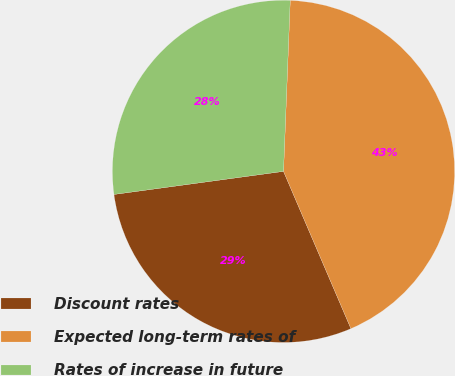Convert chart to OTSL. <chart><loc_0><loc_0><loc_500><loc_500><pie_chart><fcel>Discount rates<fcel>Expected long-term rates of<fcel>Rates of increase in future<nl><fcel>29.29%<fcel>42.93%<fcel>27.78%<nl></chart> 